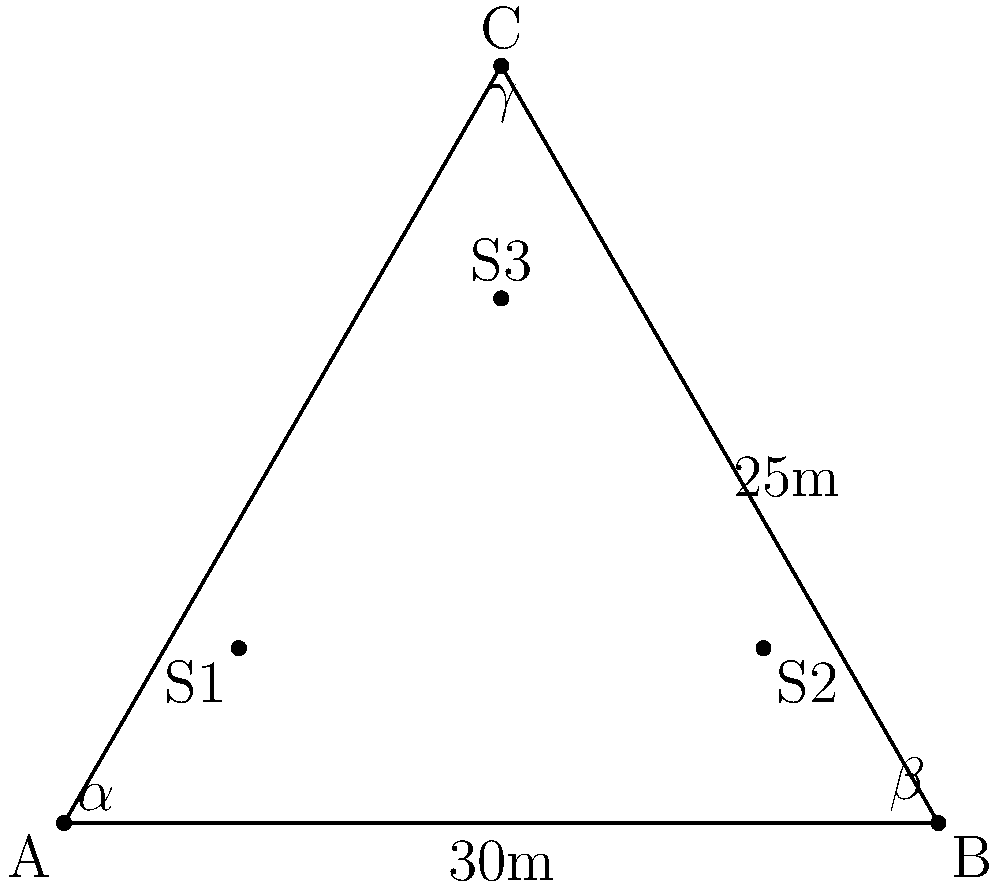As a cinema verite filmmaker, you're setting up a triangular microphone array to capture realistic sound effects for your documentary. The sides of the triangle measure 30m, 25m, and 28m. Three sound sources (S1, S2, and S3) are placed within this triangle. If the angle $\alpha$ (at vertex A) is 52°, what is the measure of angle $\beta$ (at vertex B)? To solve this problem, we'll use the law of sines. Here's the step-by-step solution:

1) First, let's recall the law of sines:

   $$\frac{a}{\sin A} = \frac{b}{\sin B} = \frac{c}{\sin C}$$

   where $a$, $b$, and $c$ are the lengths of the sides opposite to angles $A$, $B$, and $C$ respectively.

2) We know:
   - Side $c$ (opposite to angle $C$) = 30m
   - Side $a$ (opposite to angle $A$ or $\alpha$) = 25m
   - Angle $A$ or $\alpha$ = 52°
   - We need to find angle $B$ or $\beta$

3) Let's use the law of sines with the known values:

   $$\frac{25}{\sin 52°} = \frac{30}{\sin \beta}$$

4) Cross multiply:

   $$25 \sin \beta = 30 \sin 52°$$

5) Solve for $\sin \beta$:

   $$\sin \beta = \frac{30 \sin 52°}{25}$$

6) Use a calculator to evaluate:

   $$\sin \beta \approx 0.9397$$

7) To get $\beta$, we need to take the inverse sine (arcsin):

   $$\beta = \arcsin(0.9397) \approx 70.3°$$

Therefore, angle $\beta$ is approximately 70.3°.
Answer: 70.3° 